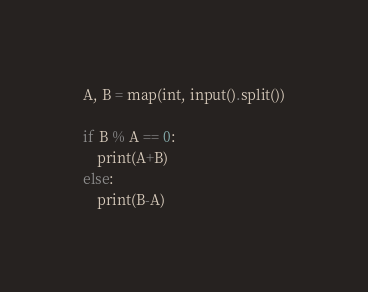Convert code to text. <code><loc_0><loc_0><loc_500><loc_500><_Python_>A, B = map(int, input().split())

if B % A == 0:
	print(A+B)
else:
	print(B-A)</code> 